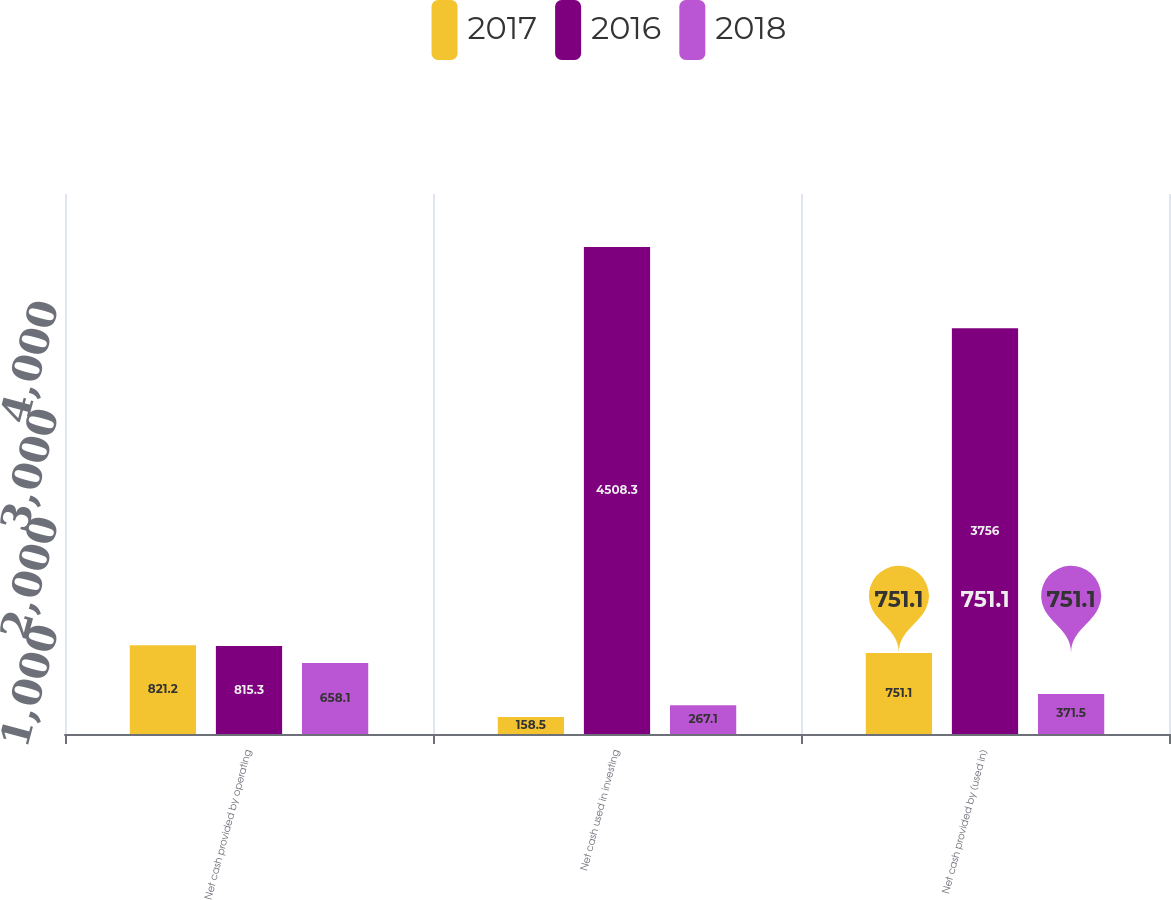<chart> <loc_0><loc_0><loc_500><loc_500><stacked_bar_chart><ecel><fcel>Net cash provided by operating<fcel>Net cash used in investing<fcel>Net cash provided by (used in)<nl><fcel>2017<fcel>821.2<fcel>158.5<fcel>751.1<nl><fcel>2016<fcel>815.3<fcel>4508.3<fcel>3756<nl><fcel>2018<fcel>658.1<fcel>267.1<fcel>371.5<nl></chart> 